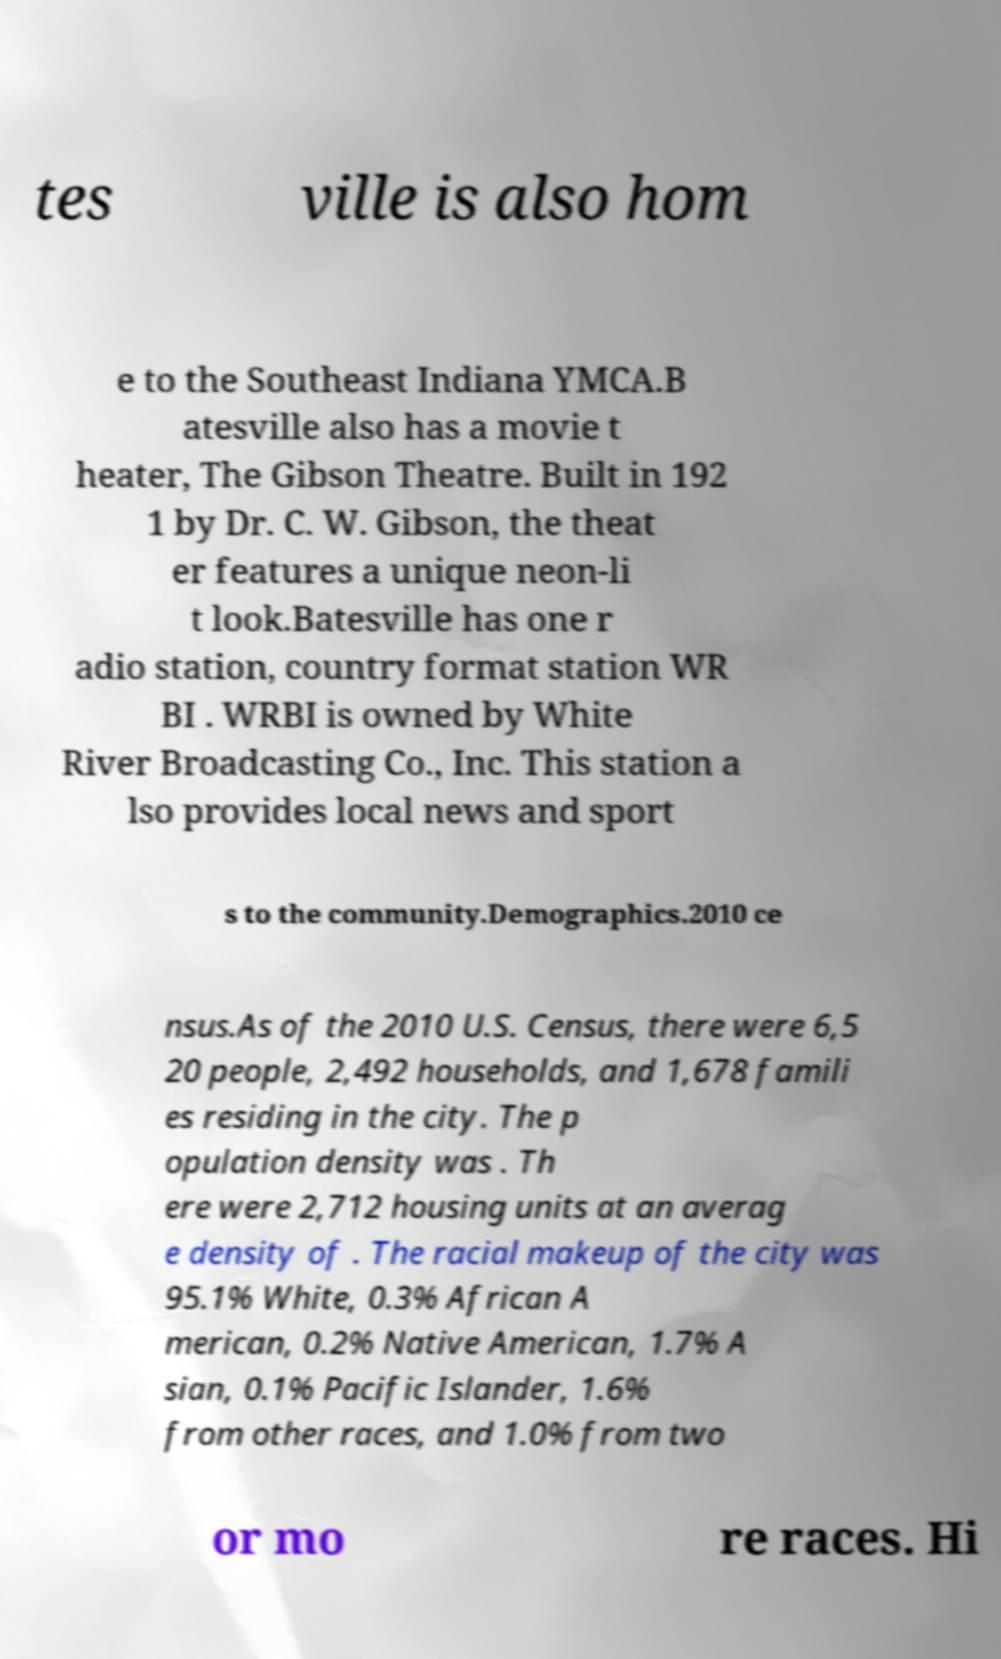Could you assist in decoding the text presented in this image and type it out clearly? tes ville is also hom e to the Southeast Indiana YMCA.B atesville also has a movie t heater, The Gibson Theatre. Built in 192 1 by Dr. C. W. Gibson, the theat er features a unique neon-li t look.Batesville has one r adio station, country format station WR BI . WRBI is owned by White River Broadcasting Co., Inc. This station a lso provides local news and sport s to the community.Demographics.2010 ce nsus.As of the 2010 U.S. Census, there were 6,5 20 people, 2,492 households, and 1,678 famili es residing in the city. The p opulation density was . Th ere were 2,712 housing units at an averag e density of . The racial makeup of the city was 95.1% White, 0.3% African A merican, 0.2% Native American, 1.7% A sian, 0.1% Pacific Islander, 1.6% from other races, and 1.0% from two or mo re races. Hi 